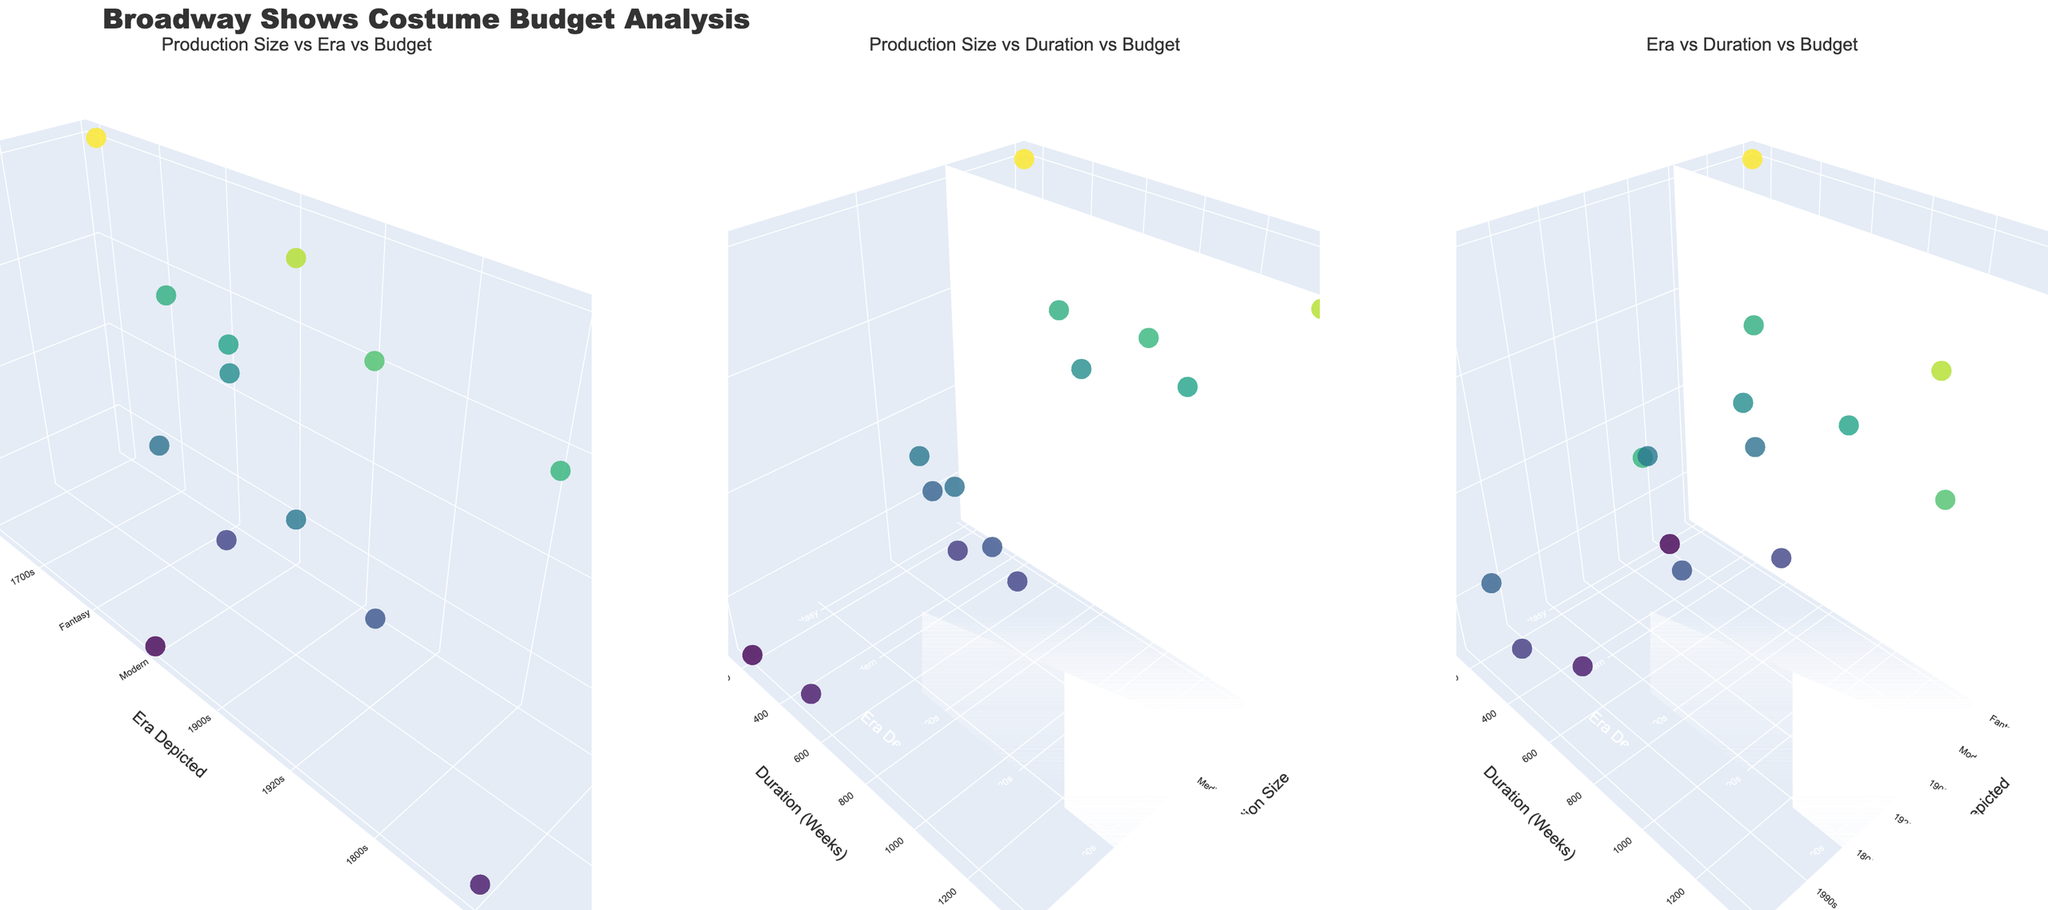What is the title of the entire figure? The title is prominently displayed at the top of the figure. It gives an overall summary of what the figure is about.
Answer: Broadway Shows Costume Budget Analysis Which era depicted has the highest costume budget in the "Era vs Duration vs Budget" subplot? Observe the "Era Depicted" axis in the third subplot and identify which era has the highest point on the "Costume Budget" axis.
Answer: 1930s How many shows fall under the 'Modern' era depicted in the "Production Size vs Era vs Budget" subplot? Count the number of markers that fall under the 'Modern' category on the "Era Depicted" axis in the first subplot.
Answer: 3 Which show has the lowest costume budget, and what is its production size? Look at the markers to find the one with the lowest position on the "Costume Budget" axis and note the corresponding show and its "Production Size".
Answer: Dear Evan Hansen, Small How does the budget for 'The Sound of Music' compare with 'Hamilton' in the "Production Size vs Era vs Budget" subplot? Locate the markers representing 'The Sound of Music' and 'Hamilton' on the "Costume Budget" axis in the first subplot and compare their positions.
Answer: 'The Sound of Music' has a higher budget than 'Hamilton' What are the production sizes of the shows that have a costume budget of over $200,000? Look at the markers above the $200,000 mark on the "Costume Budget" axis in any subplot and note their corresponding "Production Sizes".
Answer: Large Which era depicted has the most varied (widest range of) show durations in the "Era vs Duration vs Budget" subplot? Observe the spread of markers along the "Duration (Weeks)" axis in the third subplot for each "Era Depicted" and determine which has the widest spread.
Answer: Modern In the "Production Size vs Duration vs Budget" subplot, which production size appears to have the highest average costume budget? Estimate the average position of markers on the "Costume Budget" axis for each "Production Size" and identify the highest one.
Answer: Large 